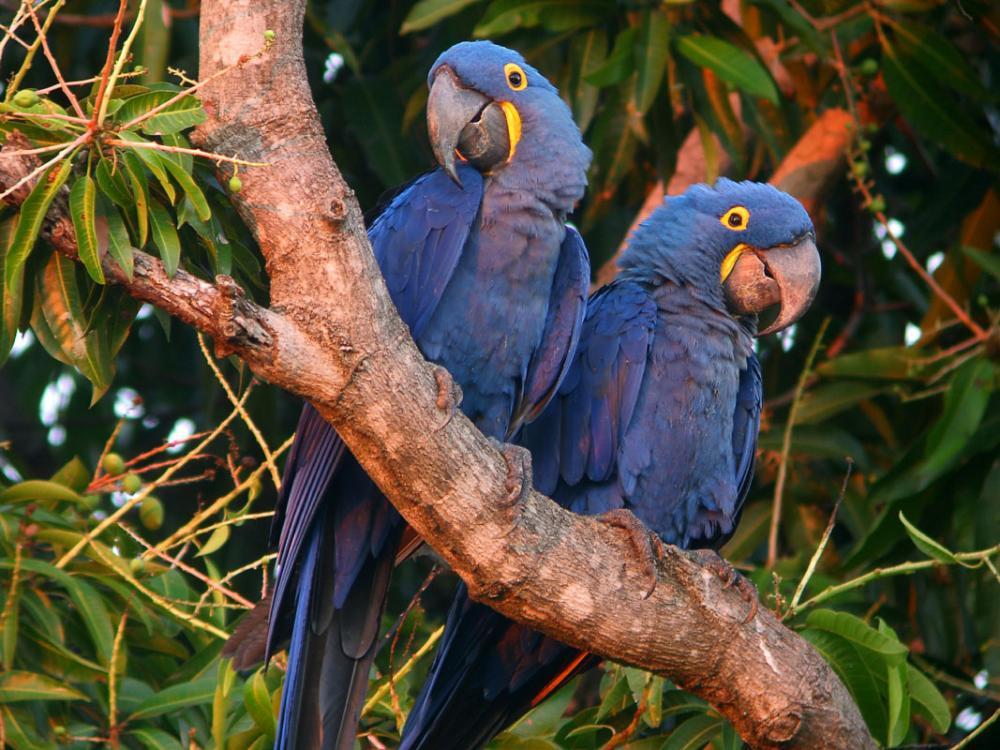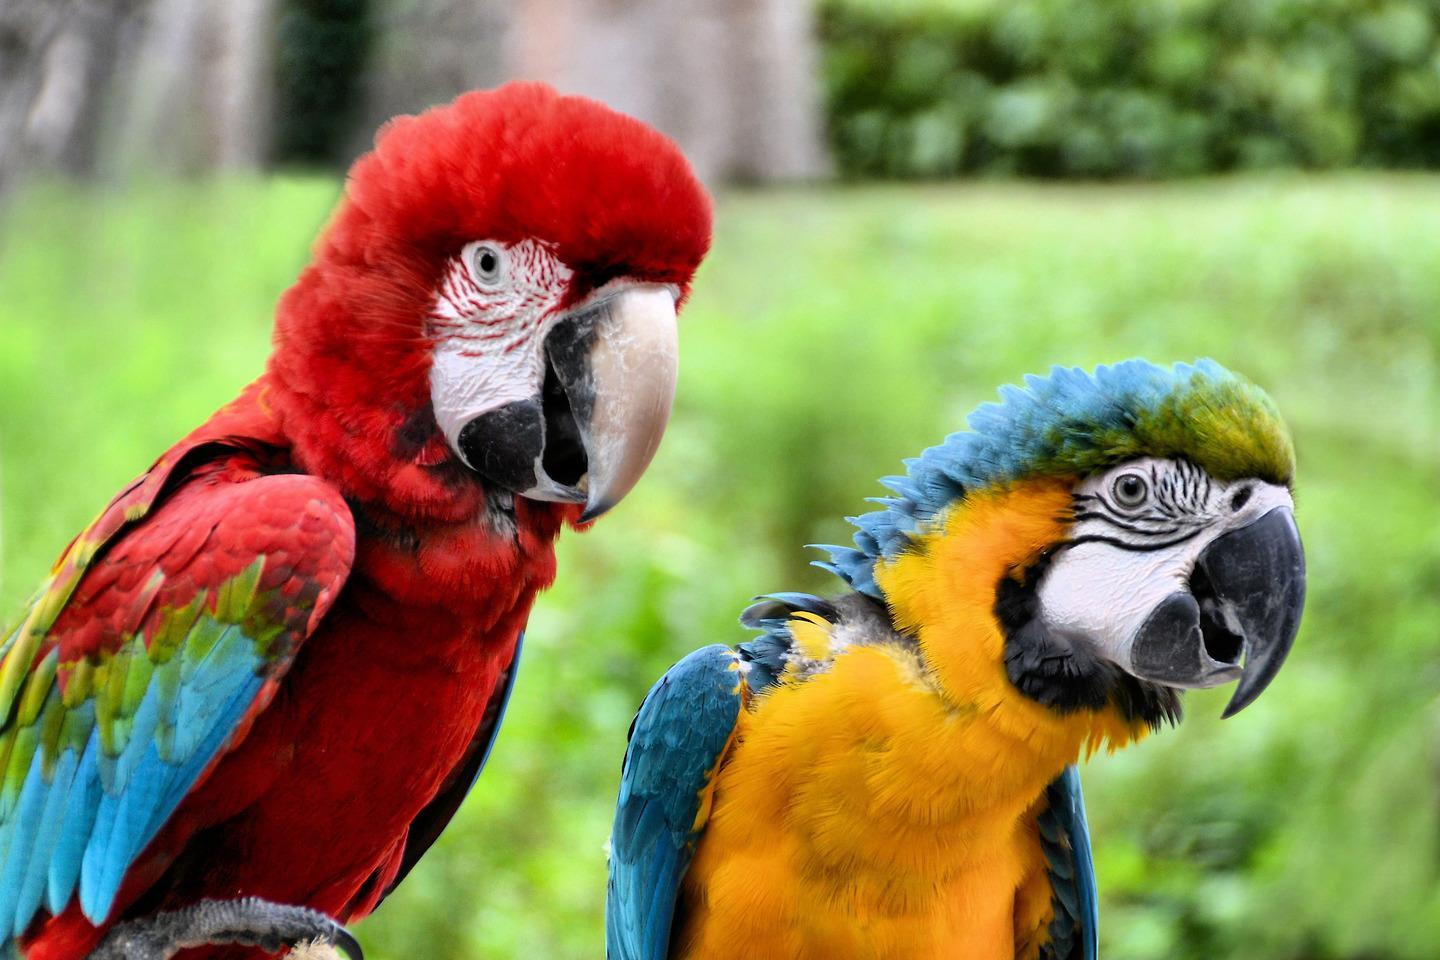The first image is the image on the left, the second image is the image on the right. Examine the images to the left and right. Is the description "There are two blue birds perching on the same branch in one of the images." accurate? Answer yes or no. Yes. The first image is the image on the left, the second image is the image on the right. Given the left and right images, does the statement "One image shows two solid-blue parrots perched on a branch, and the other image shows one red-headed bird next to a blue-and-yellow bird." hold true? Answer yes or no. Yes. 